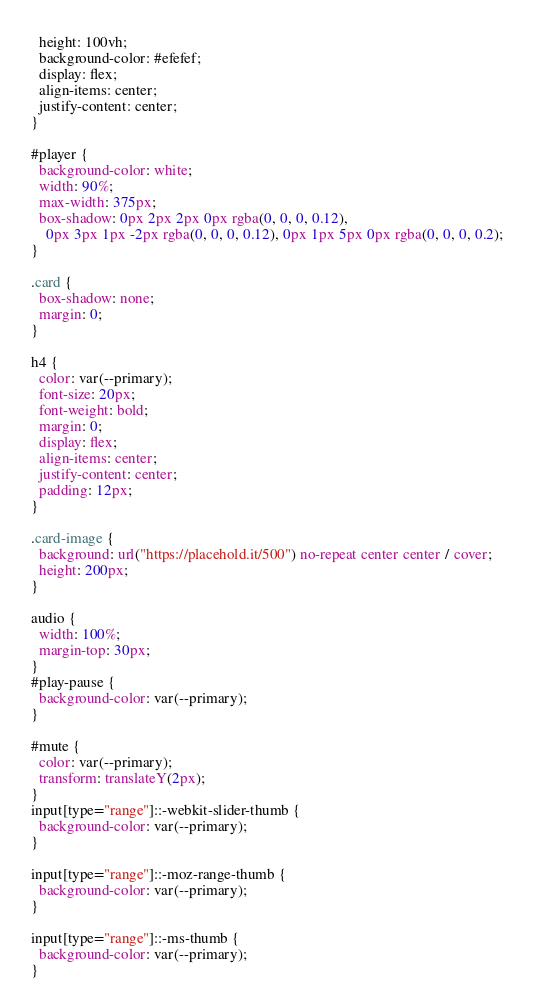Convert code to text. <code><loc_0><loc_0><loc_500><loc_500><_CSS_>  height: 100vh;
  background-color: #efefef;
  display: flex;
  align-items: center;
  justify-content: center;
}

#player {
  background-color: white;
  width: 90%;
  max-width: 375px;
  box-shadow: 0px 2px 2px 0px rgba(0, 0, 0, 0.12),
    0px 3px 1px -2px rgba(0, 0, 0, 0.12), 0px 1px 5px 0px rgba(0, 0, 0, 0.2);
}

.card {
  box-shadow: none;
  margin: 0;
}

h4 {
  color: var(--primary);
  font-size: 20px;
  font-weight: bold;
  margin: 0;
  display: flex;
  align-items: center;
  justify-content: center;
  padding: 12px;
}

.card-image {
  background: url("https://placehold.it/500") no-repeat center center / cover;
  height: 200px;
}

audio {
  width: 100%;
  margin-top: 30px;
}
#play-pause {
  background-color: var(--primary);
}

#mute {
  color: var(--primary);
  transform: translateY(2px);
}
input[type="range"]::-webkit-slider-thumb {
  background-color: var(--primary);
}

input[type="range"]::-moz-range-thumb {
  background-color: var(--primary);
}

input[type="range"]::-ms-thumb {
  background-color: var(--primary);
}</code> 